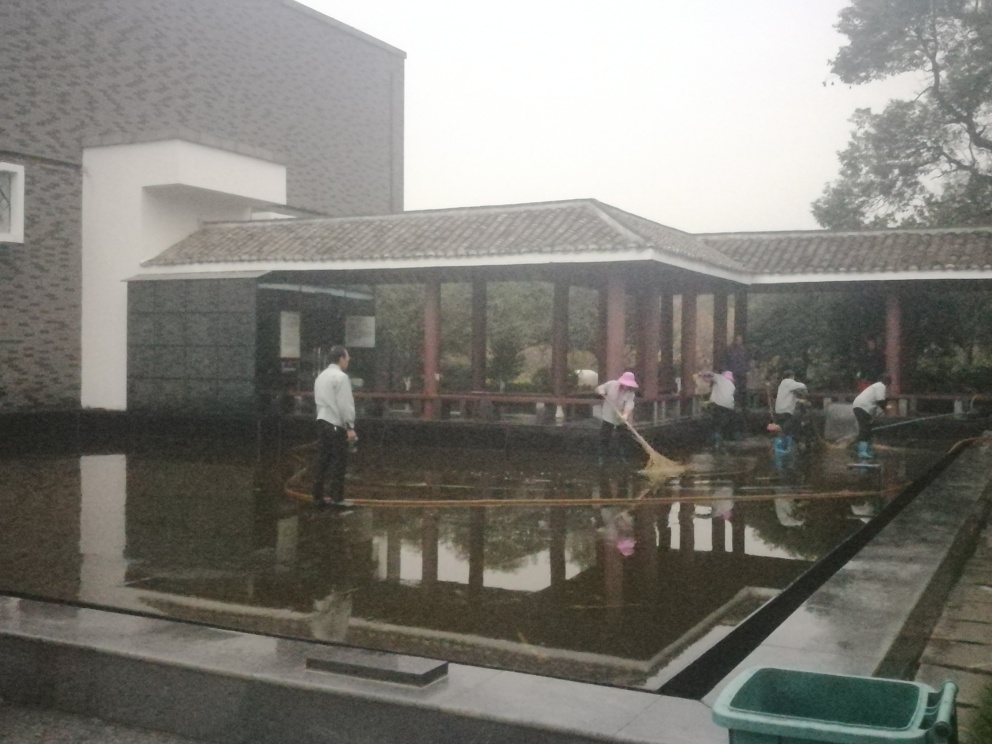How is the background of the image?
A. Focused
B. Blurry.
C. Clear
D. Detailed The background of the image provides context rather than focus, displaying architectural elements and trees in a manner that supports the primary subjects without detracting from them. Therefore, the correct answer would be B. Blurry, as the background is not the main focus, which helps in drawing attention to the activities occurring in the foreground. 